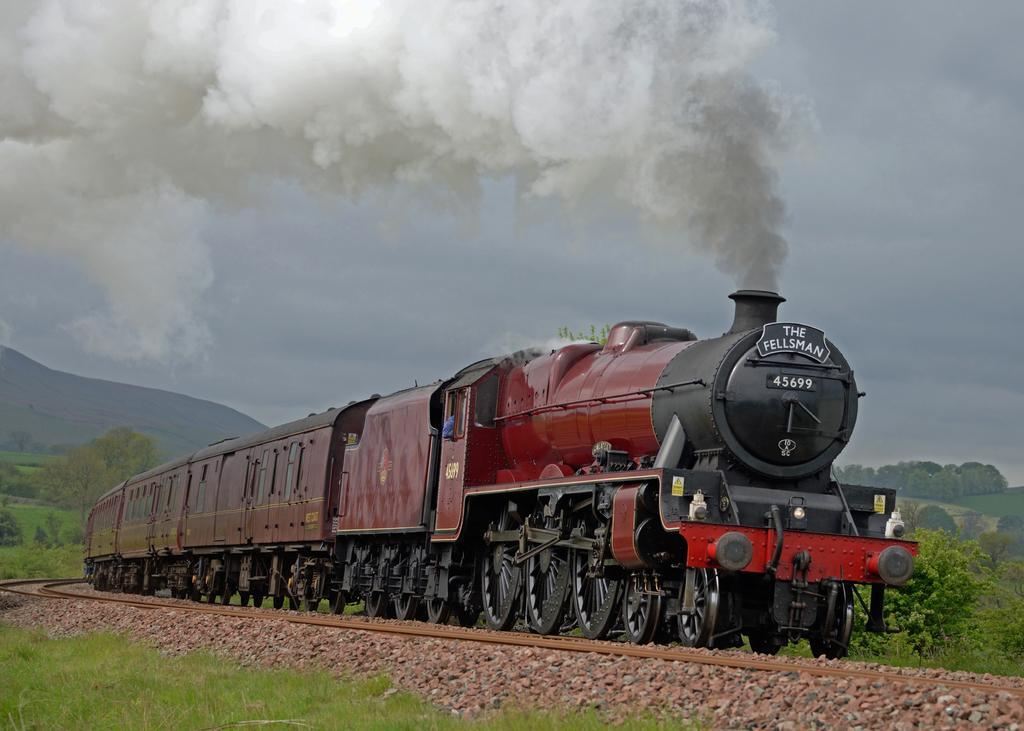Can you describe this image briefly? There is a train on the track. Here we can see grass, stones, trees, and smoke. In the background we can see a mountain and sky. 